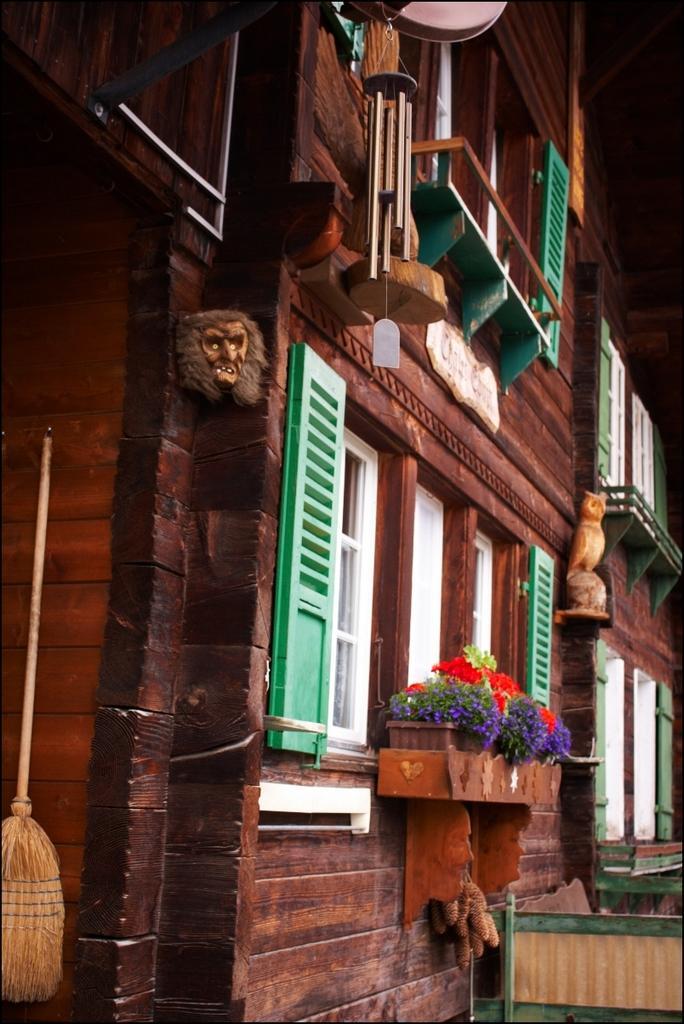How would you summarize this image in a sentence or two? In this image there is a wooden object on the right corner. There is a building, there are windows, potted plants with flowers, there is a wooden railing, there is a metal object, there are wooden objects on the left corner. 